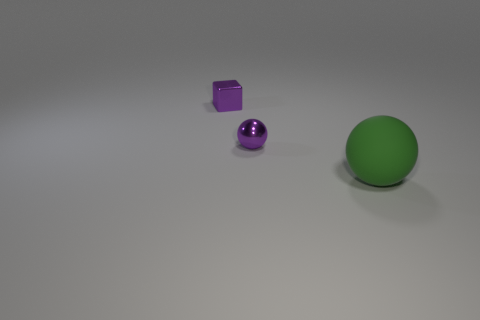Add 2 tiny blue matte balls. How many objects exist? 5 Subtract all balls. How many objects are left? 1 Add 2 green matte balls. How many green matte balls are left? 3 Add 1 small purple metallic cubes. How many small purple metallic cubes exist? 2 Subtract 0 brown cylinders. How many objects are left? 3 Subtract all purple balls. Subtract all shiny blocks. How many objects are left? 1 